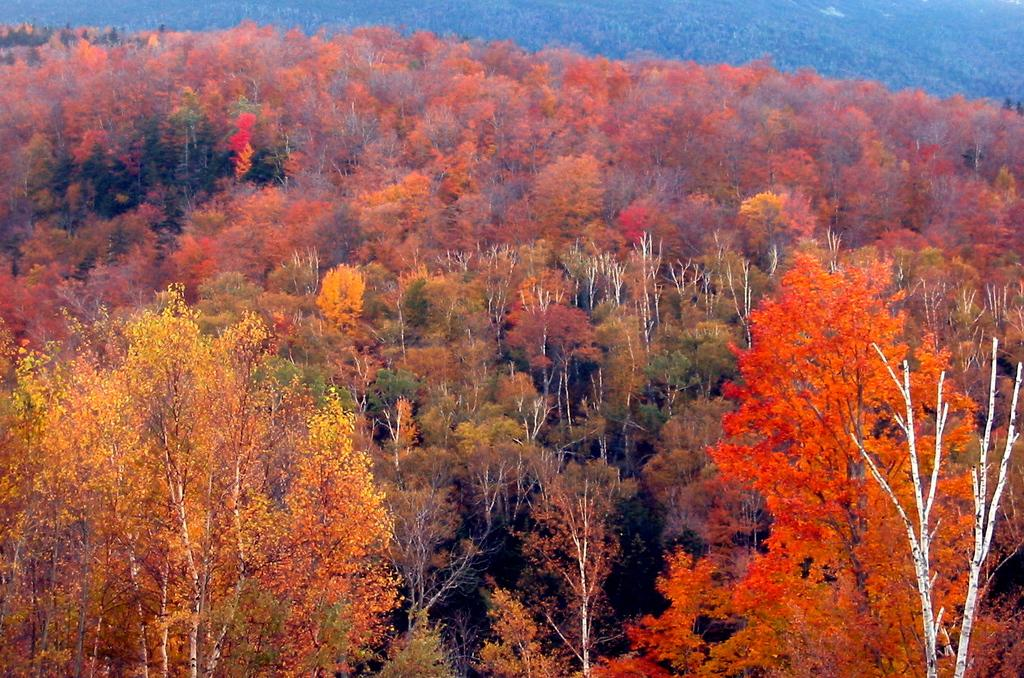What type of vegetation can be seen in the image? There are multiple trees in the image. What colors are the trees in the image? The trees have varying colors, including yellow, red, orange, and green. What type of flowers can be seen in the bedroom in the image? There is no bedroom or flowers present in the image; it features multiple trees with varying colors. 